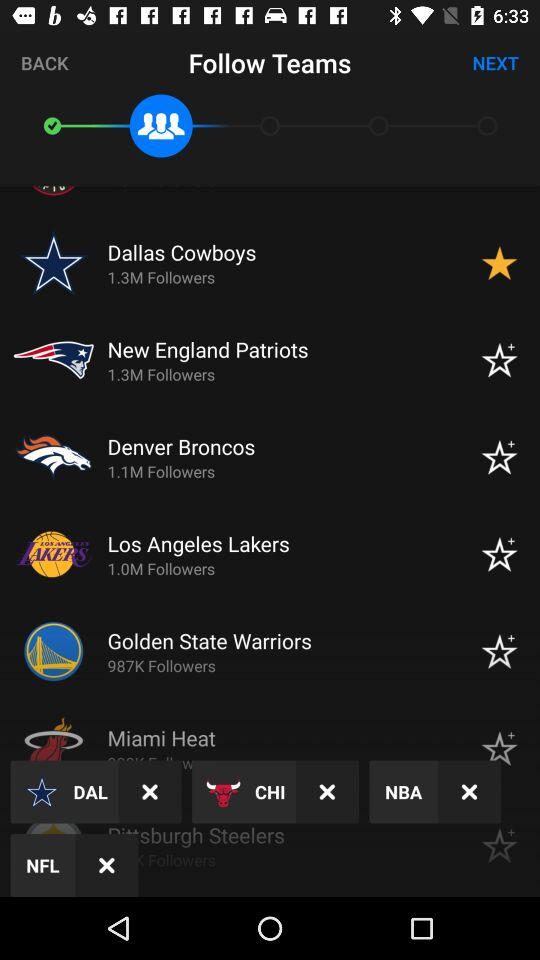What team was marked as starred? The team is the "Dallas Cowboys". 